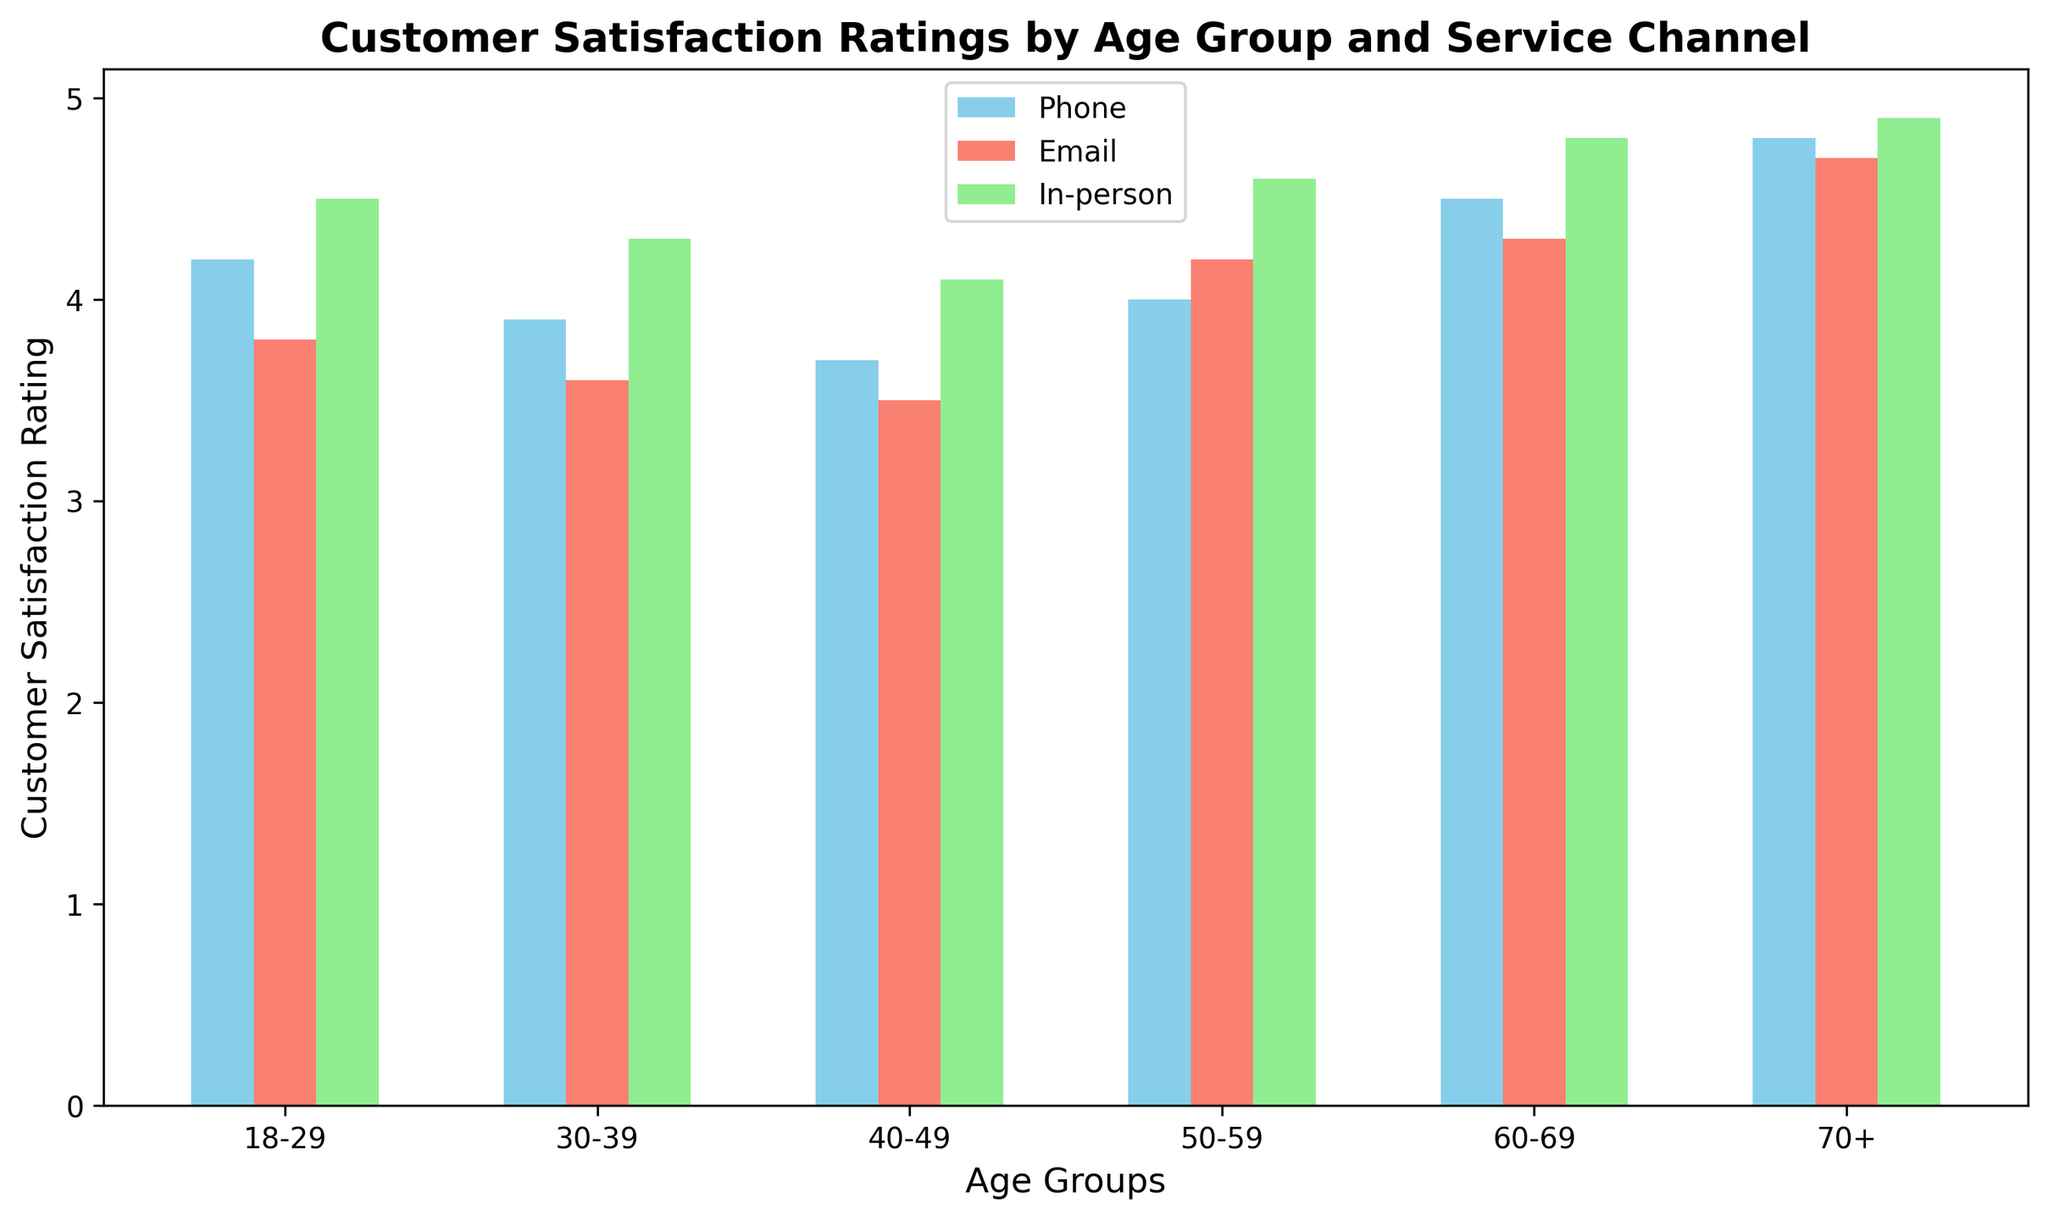Which age group gave the highest customer satisfaction rating for in-person service? To find the age group with the highest in-person satisfaction rating, I look at the heights of the green bars and compare them across the age groups.
Answer: 70+ Which service channel received the lowest satisfaction rating from the 40-49 age group? For the 40-49 age group, I compare the heights of the blue, red, and green bars. The red bar (Email) is the shortest.
Answer: Email How much higher is the in-person satisfaction rating for the 70+ age group compared to the 30-39 age group? Look at the green bars for both age groups. The rating for 70+ is 4.9 and for 30-39 is 4.3. Subtract the smaller rating from the larger one: 4.9 - 4.3 = 0.6.
Answer: 0.6 What is the average customer satisfaction rating for email service across all age groups? Sum the heights of the red bars and divide by the number of age groups. (3.8 + 3.6 + 3.5 + 4.2 + 4.3 + 4.7) / 6 = 4.02
Answer: 4.02 Which service channel generally receives the highest satisfaction ratings across age groups? Compare the heights of the blue, red, and green bars overall; the green (in-person) bars are generally tallest.
Answer: In-person For the 18-29 age group, how much do the satisfaction ratings for phone and in-person services add up to? Add the heights of the blue and green bars for the 18-29 age group. 4.2 (Phone) + 4.5 (In-person) = 8.7
Answer: 8.7 Which age group has the most significant drop in satisfaction rating between in-person and email service? Calculate the differences between the green and red bars for each age group. The 18-29 age group has the most significant drop (4.5 - 3.8 = 0.7).
Answer: 18-29 